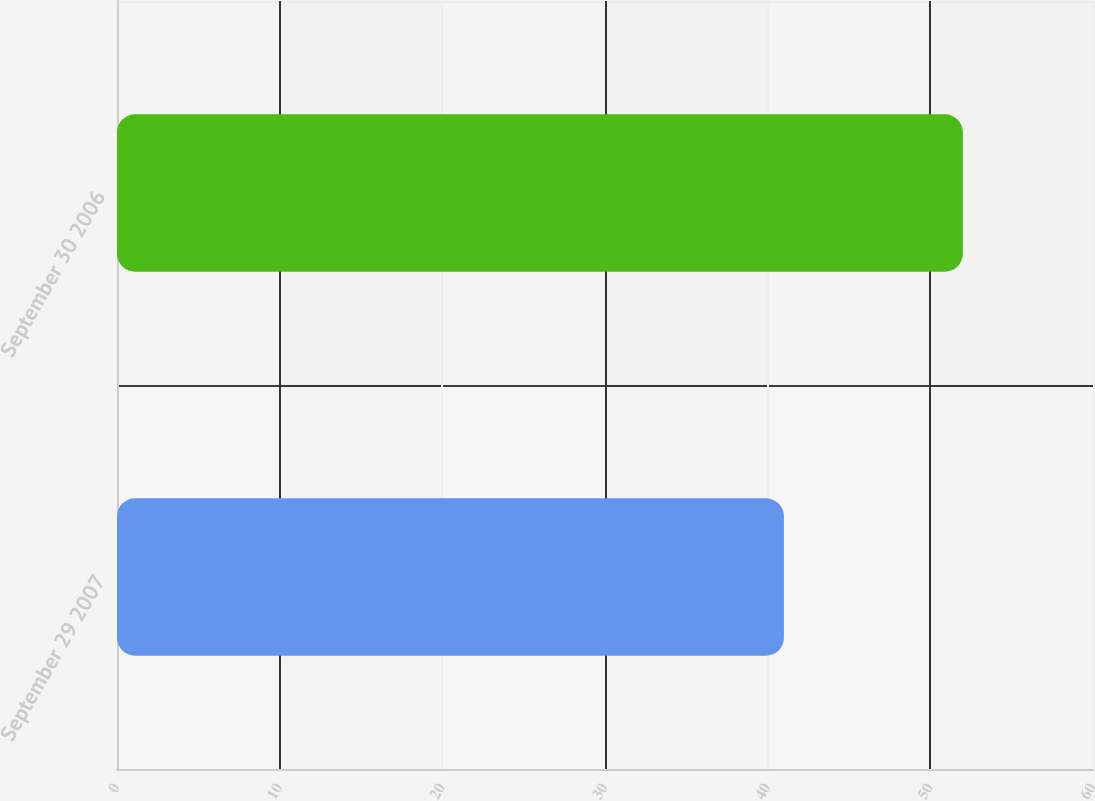<chart> <loc_0><loc_0><loc_500><loc_500><bar_chart><fcel>September 29 2007<fcel>September 30 2006<nl><fcel>41<fcel>52<nl></chart> 